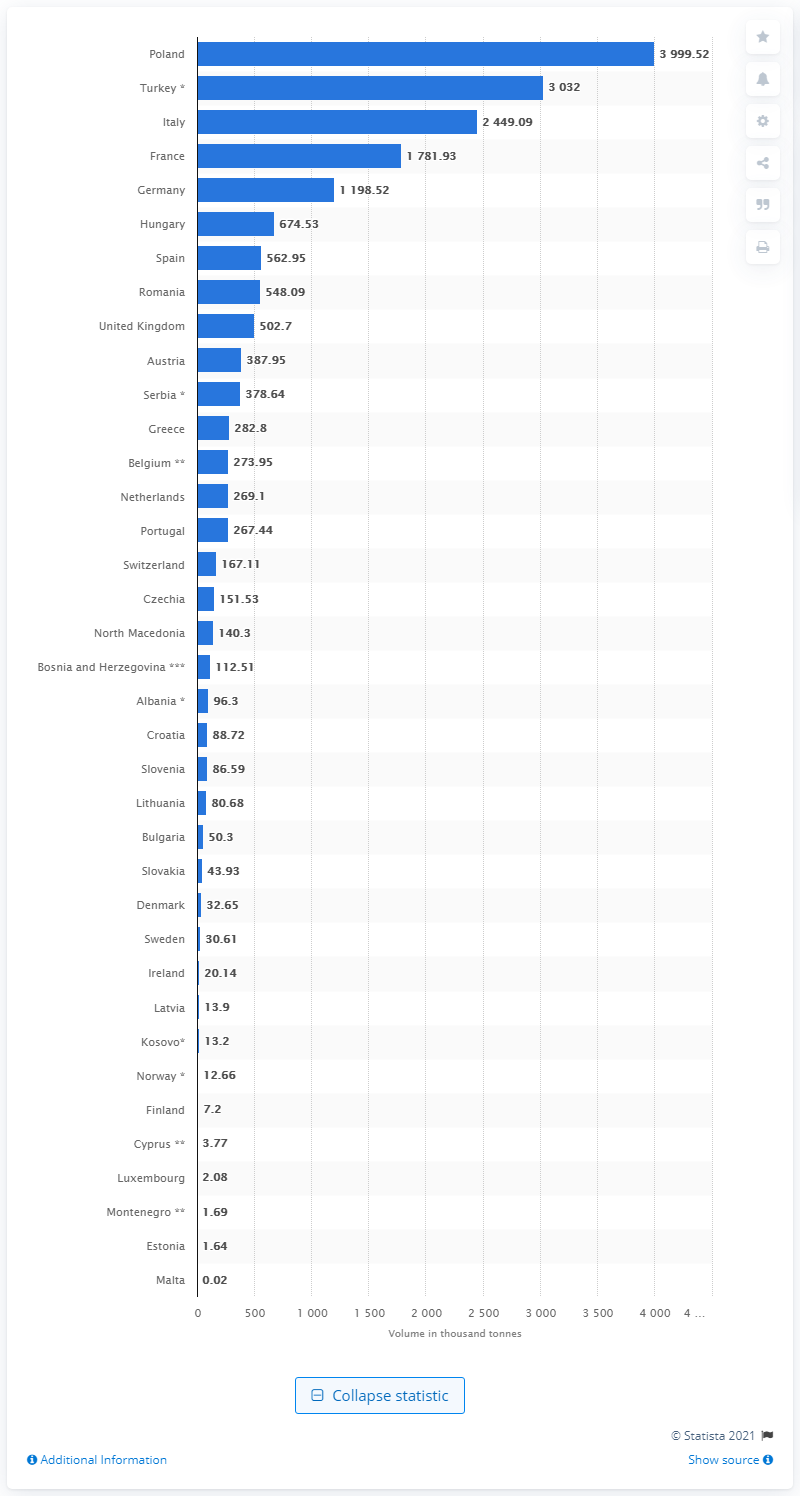Indicate a few pertinent items in this graphic. In 2018, the largest volume of apples was produced by Poland. 